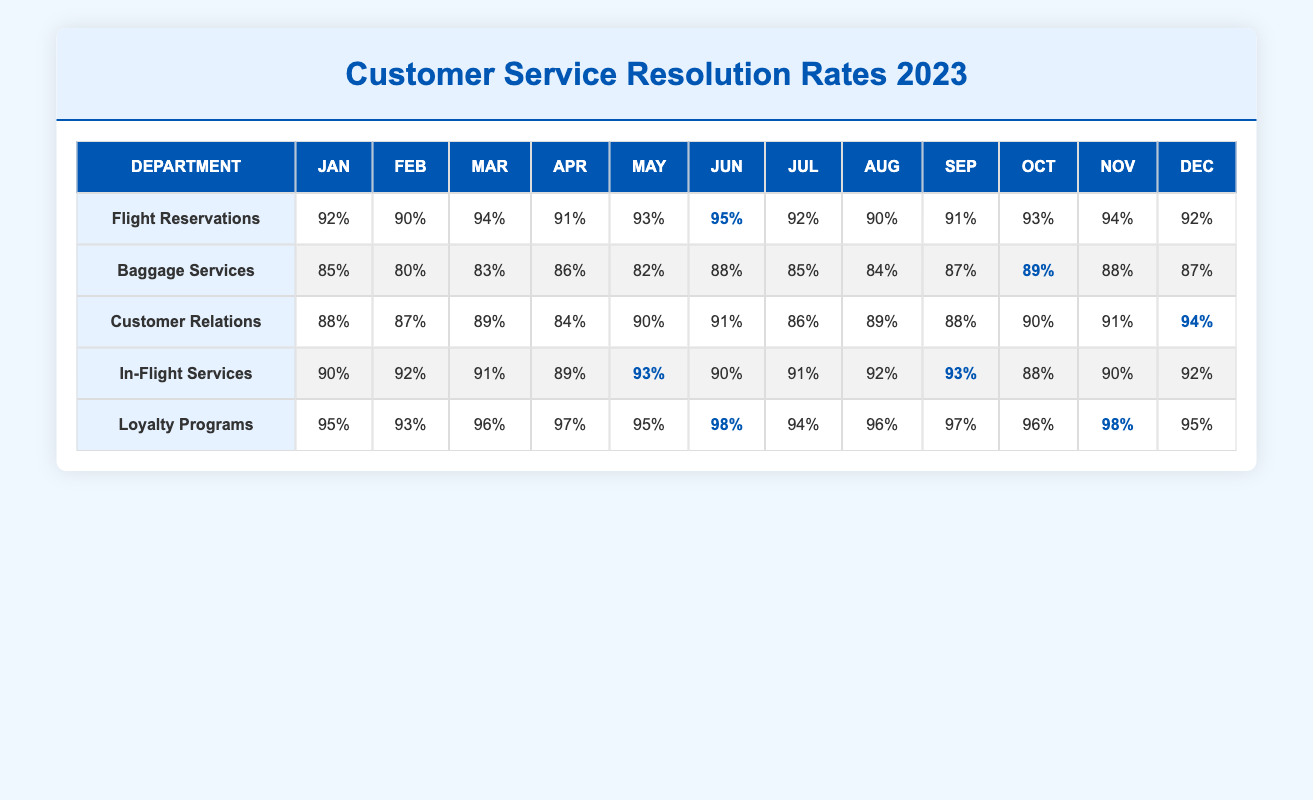What was the resolution rate for Customer Relations in March? The table shows that the resolution rate for Customer Relations in March is listed directly in the row for that department and column for March, which is 89%.
Answer: 89% Which department achieved the highest resolution rate in June? Looking at the June column for each department, the highest resolution rate is found under Loyalty Programs, which is 98%.
Answer: 98% What is the average resolution rate for Baggage Services over the year? To find the average for Baggage Services, add the rates for each month: (85 + 80 + 83 + 86 + 82 + 88 + 85 + 84 + 87 + 89 + 88 + 87) = 1020. There are 12 months, so the average is 1020/12 = 85.
Answer: 85 Did the In-Flight Services department ever have a resolution rate below 90%? By examining the In-Flight Services row, we see that the lowest resolution rate is in April, which is 89%. Therefore, it did dip below 90% in that month.
Answer: Yes What was the difference in resolution rates between Loyalty Programs and Flight Reservations in October? In October, the rate for Loyalty Programs is 96% and for Flight Reservations is 93%. The difference can be calculated as 96 - 93 = 3%.
Answer: 3 Which month had the lowest resolution rate for Customer Relations? Reviewing the Customer Relations column, the lowest resolution rate occurs in April at 84%.
Answer: 84 If we combine the resolution rates for all departments in May, what is the total? The resolution rates in May are: Flight Reservations (93), Baggage Services (82), Customer Relations (90), In-Flight Services (93), and Loyalty Programs (95). Summing these gives: 93 + 82 + 90 + 93 + 95 = 453.
Answer: 453 In which month did Baggage Services show the highest improvement compared to the previous month? Reviewing the Baggage Services row, we see the rates for March (83%) and April (86%), where improvement from March to April is +3%. The subsequent months are either lower or have only minor increases, suggesting April is the highest improvement.
Answer: April What was the trend of resolution rates in Loyalty Programs from January to December? By analyzing the Loyalty Programs rates from January (95%) to December (95%), we observe a general increase from January to June, peaking at 98%, followed by a decline in October (96% but remaining over 95) before stabilizing at 95% in December. The trend indicates initial growth, peak performance, and stabilization by year's end.
Answer: Initial growth with stabilization 